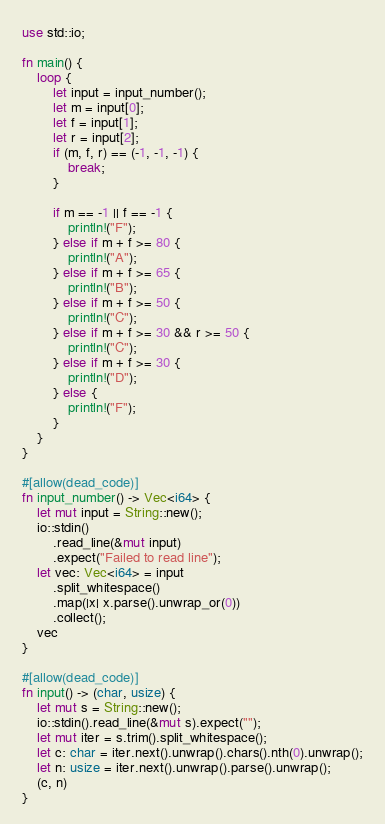Convert code to text. <code><loc_0><loc_0><loc_500><loc_500><_Rust_>use std::io;

fn main() {
    loop {
        let input = input_number();
        let m = input[0];
        let f = input[1];
        let r = input[2];
        if (m, f, r) == (-1, -1, -1) {
            break;
        }

        if m == -1 || f == -1 {
            println!("F");
        } else if m + f >= 80 {
            println!("A");
        } else if m + f >= 65 {
            println!("B");
        } else if m + f >= 50 {
            println!("C");
        } else if m + f >= 30 && r >= 50 {
            println!("C");
        } else if m + f >= 30 {
            println!("D");
        } else {
            println!("F");
        }
    }
}

#[allow(dead_code)]
fn input_number() -> Vec<i64> {
    let mut input = String::new();
    io::stdin()
        .read_line(&mut input)
        .expect("Failed to read line");
    let vec: Vec<i64> = input
        .split_whitespace()
        .map(|x| x.parse().unwrap_or(0))
        .collect();
    vec
}

#[allow(dead_code)]
fn input() -> (char, usize) {
    let mut s = String::new();
    io::stdin().read_line(&mut s).expect("");
    let mut iter = s.trim().split_whitespace();
    let c: char = iter.next().unwrap().chars().nth(0).unwrap();
    let n: usize = iter.next().unwrap().parse().unwrap();
    (c, n)
}

</code> 